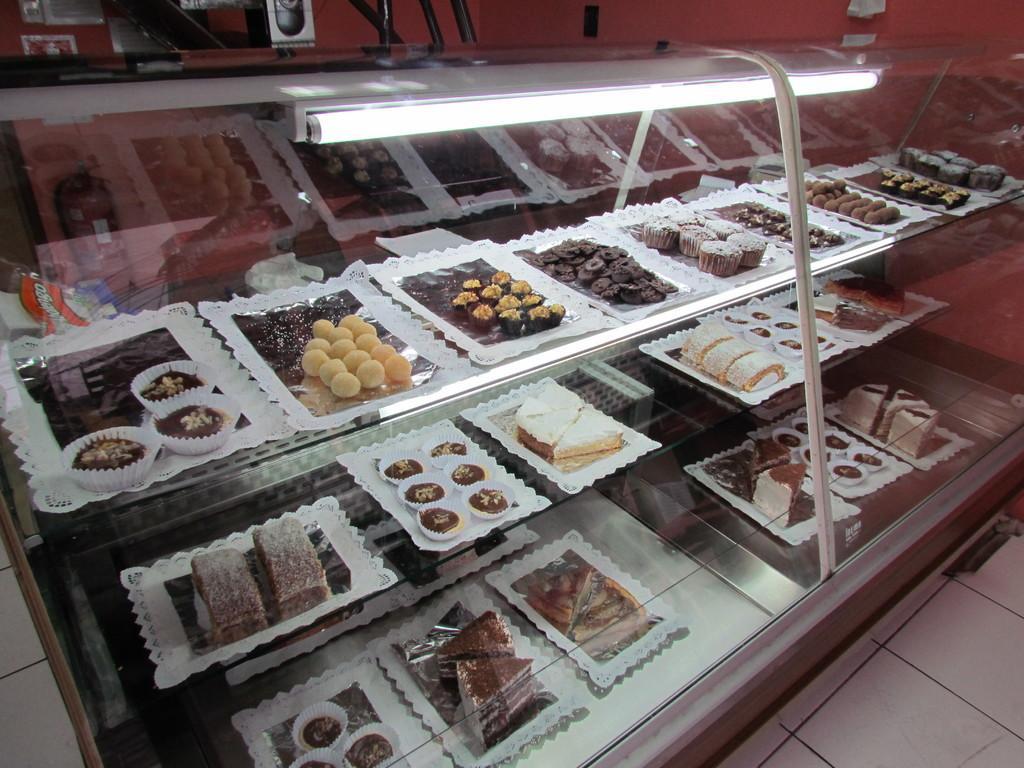Could you give a brief overview of what you see in this image? In this picture we can see tube light, glass, food items and aluminium foils placed in trays and these trays are placed in racks and in the background we can see some objects and walls. 